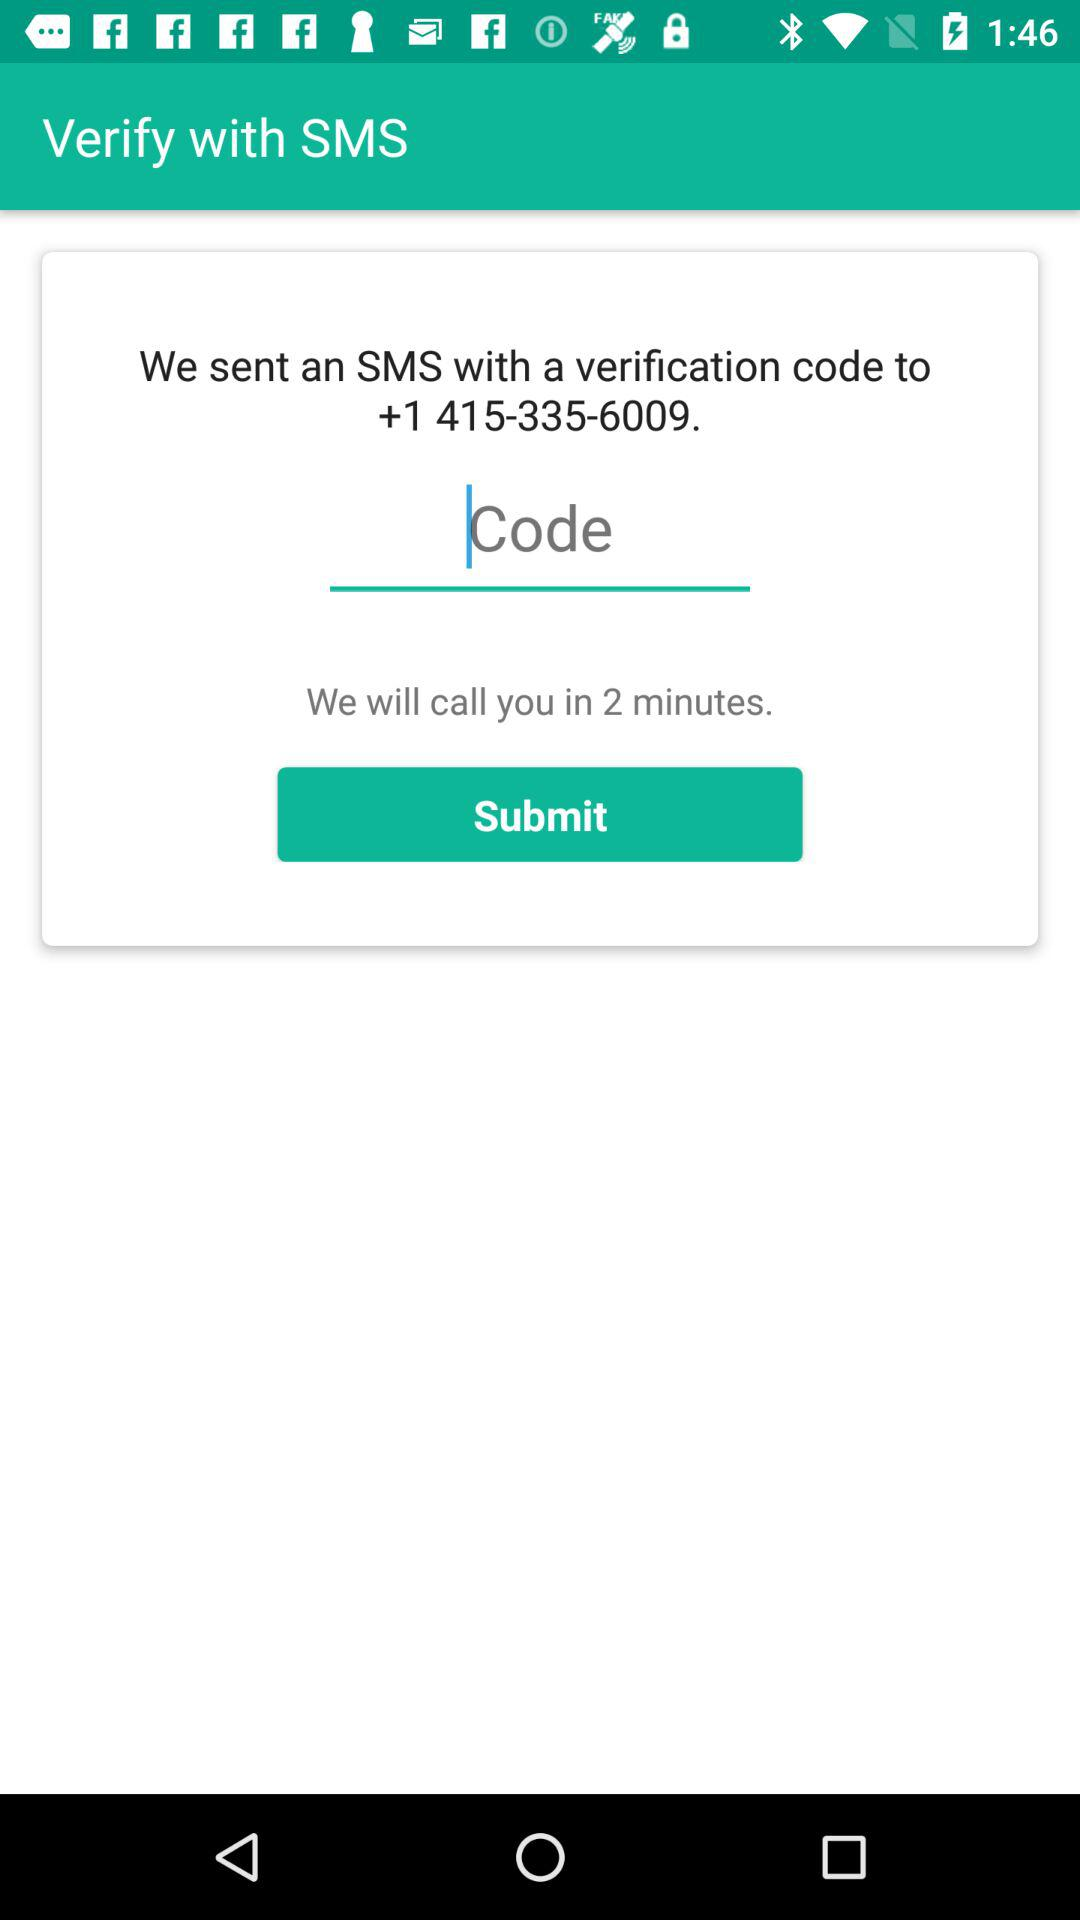What is the contact number for OTP? The contact number is +1 415-335-6009. 